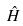Convert formula to latex. <formula><loc_0><loc_0><loc_500><loc_500>\hat { H }</formula> 